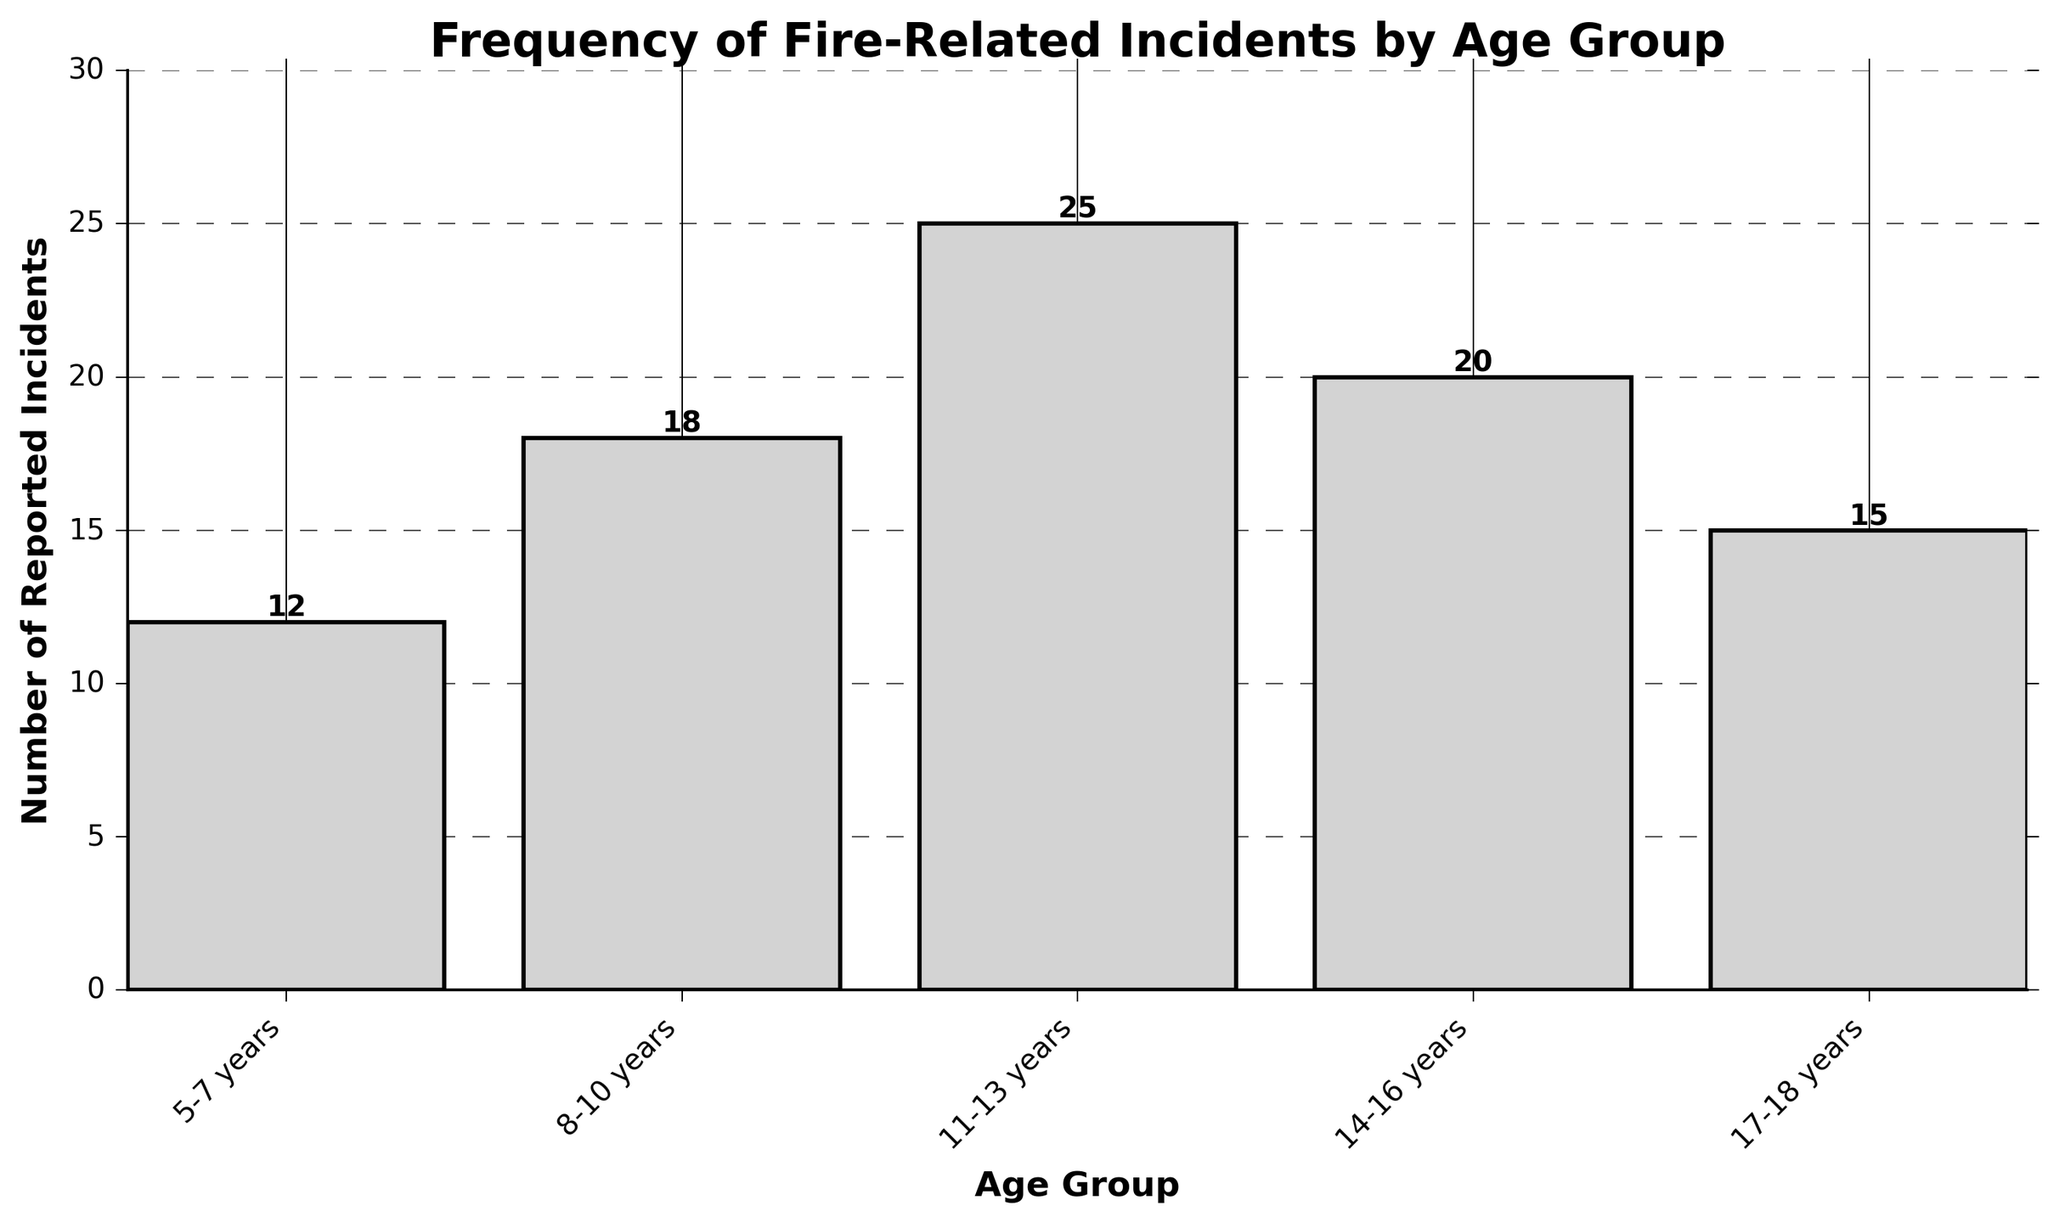Which age group reported the highest number of fire-related incidents? The bar representing the 11-13 years age group is the tallest, indicating the highest number with a value of 25.
Answer: 11-13 years What is the total number of fire-related incidents reported across all age groups? Sum up the reported incidents for each age group: 12 + 18 + 25 + 20 + 15 = 90.
Answer: 90 Which age group reported fewer incidents, 8-10 years or 14-16 years? Compare the heights of the bars for the 8-10 years and 14-16 years age groups. 8-10 years has 18 incidents, while 14-16 years has 20 incidents.
Answer: 8-10 years What is the difference in the number of incidents reported between the age groups 5-7 years and 11-13 years? Subtract the number of incidents for 5-7 years from 11-13 years: 25 - 12 = 13.
Answer: 13 What is the average number of incidents reported for age groups 5-7 years, 8-10 years, and 17-18 years? Add the incidents for these age groups and divide by 3: (12 + 18 + 15) / 3 = 45 / 3 = 15.
Answer: 15 How many more incidents were reported by the 11-13 years group compared to the 17-18 years group? Subtract the number of incidents for 17-18 years from 11-13 years: 25 - 15 = 10.
Answer: 10 Does the 17-18 years group report more incidents than the 5-7 years group? Compare the heights of the bars for 17-18 years and 5-7 years: 15 for 17-18 years and 12 for 5-7 years.
Answer: Yes What proportion of the total incidents were reported by the 14-16 years age group? Divide the incidents for 14-16 years by the total incidents and convert to a percentage: (20 / 90) * 100 = 22.22%.
Answer: 22.22% Arrange the age groups in ascending order based on their reported incidents. List the values from smallest to largest using the bar heights: 5-7 years (12), 17-18 years (15), 8-10 years (18), 14-16 years (20), 11-13 years (25).
Answer: 5-7 years, 17-18 years, 8-10 years, 14-16 years, 11-13 years 